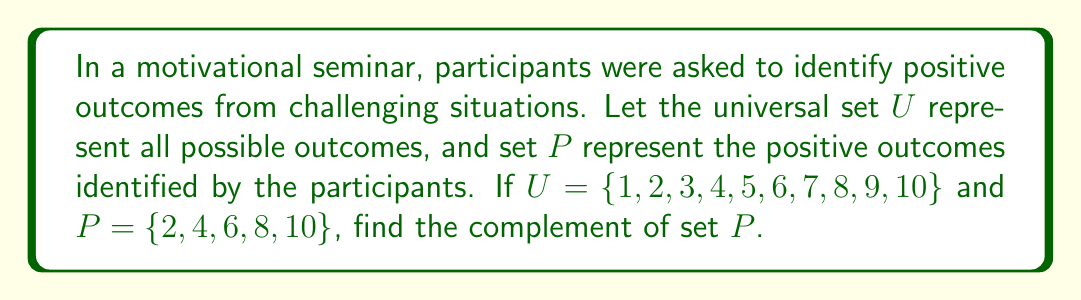Provide a solution to this math problem. To find the complement of set $P$, we need to identify all elements in the universal set $U$ that are not in set $P$. Let's approach this step-by-step:

1. First, recall that the complement of a set $A$ is denoted as $A^c$ or $\overline{A}$, and is defined as:

   $A^c = \{x \in U : x \notin A\}$

2. In this case, we're looking for $P^c$, which includes all elements in $U$ that are not in $P$.

3. We know:
   $U = \{1, 2, 3, 4, 5, 6, 7, 8, 9, 10\}$
   $P = \{2, 4, 6, 8, 10\}$

4. To find $P^c$, we need to identify the elements in $U$ that are not in $P$:
   $1 \in U$ but $1 \notin P$, so $1 \in P^c$
   $3 \in U$ but $3 \notin P$, so $3 \in P^c$
   $5 \in U$ but $5 \notin P$, so $5 \in P^c$
   $7 \in U$ but $7 \notin P$, so $7 \in P^c$
   $9 \in U$ but $9 \notin P$, so $9 \in P^c$

5. Therefore, $P^c = \{1, 3, 5, 7, 9\}$

This complement set represents the outcomes that were not identified as positive by the participants, which could be viewed as opportunities for further growth and learning in the context of a motivational seminar.
Answer: $P^c = \{1, 3, 5, 7, 9\}$ 